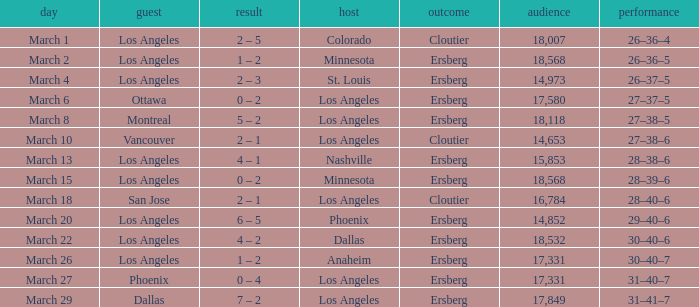I'm looking to parse the entire table for insights. Could you assist me with that? {'header': ['day', 'guest', 'result', 'host', 'outcome', 'audience', 'performance'], 'rows': [['March 1', 'Los Angeles', '2 – 5', 'Colorado', 'Cloutier', '18,007', '26–36–4'], ['March 2', 'Los Angeles', '1 – 2', 'Minnesota', 'Ersberg', '18,568', '26–36–5'], ['March 4', 'Los Angeles', '2 – 3', 'St. Louis', 'Ersberg', '14,973', '26–37–5'], ['March 6', 'Ottawa', '0 – 2', 'Los Angeles', 'Ersberg', '17,580', '27–37–5'], ['March 8', 'Montreal', '5 – 2', 'Los Angeles', 'Ersberg', '18,118', '27–38–5'], ['March 10', 'Vancouver', '2 – 1', 'Los Angeles', 'Cloutier', '14,653', '27–38–6'], ['March 13', 'Los Angeles', '4 – 1', 'Nashville', 'Ersberg', '15,853', '28–38–6'], ['March 15', 'Los Angeles', '0 – 2', 'Minnesota', 'Ersberg', '18,568', '28–39–6'], ['March 18', 'San Jose', '2 – 1', 'Los Angeles', 'Cloutier', '16,784', '28–40–6'], ['March 20', 'Los Angeles', '6 – 5', 'Phoenix', 'Ersberg', '14,852', '29–40–6'], ['March 22', 'Los Angeles', '4 – 2', 'Dallas', 'Ersberg', '18,532', '30–40–6'], ['March 26', 'Los Angeles', '1 – 2', 'Anaheim', 'Ersberg', '17,331', '30–40–7'], ['March 27', 'Phoenix', '0 – 4', 'Los Angeles', 'Ersberg', '17,331', '31–40–7'], ['March 29', 'Dallas', '7 – 2', 'Los Angeles', 'Ersberg', '17,849', '31–41–7']]} What is the Decision listed when the Home was Colorado? Cloutier. 